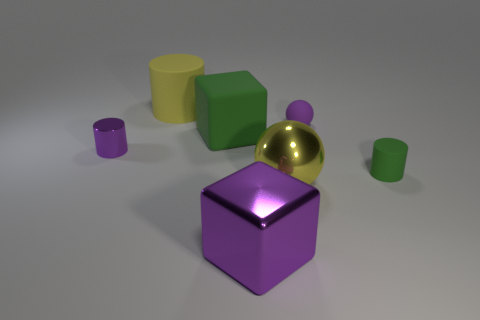There is a cylinder that is both left of the large purple metal block and in front of the big yellow rubber object; what is its material?
Keep it short and to the point. Metal. The block behind the object on the left side of the large matte cylinder is what color?
Your answer should be compact. Green. What is the material of the cube that is behind the small green cylinder?
Your answer should be very brief. Rubber. Are there fewer tiny brown rubber cylinders than tiny purple balls?
Ensure brevity in your answer.  Yes. There is a big yellow rubber thing; is its shape the same as the large purple metallic thing that is in front of the large metallic ball?
Give a very brief answer. No. There is a shiny thing that is both in front of the small green matte cylinder and left of the yellow metal sphere; what is its shape?
Give a very brief answer. Cube. Are there the same number of large cylinders that are on the right side of the tiny green object and tiny purple metallic cylinders that are in front of the shiny sphere?
Your answer should be very brief. Yes. There is a green thing on the right side of the purple rubber object; is its shape the same as the purple matte object?
Your response must be concise. No. What number of purple things are either cubes or large rubber cylinders?
Your answer should be very brief. 1. What material is the green thing that is the same shape as the big purple shiny object?
Offer a terse response. Rubber. 